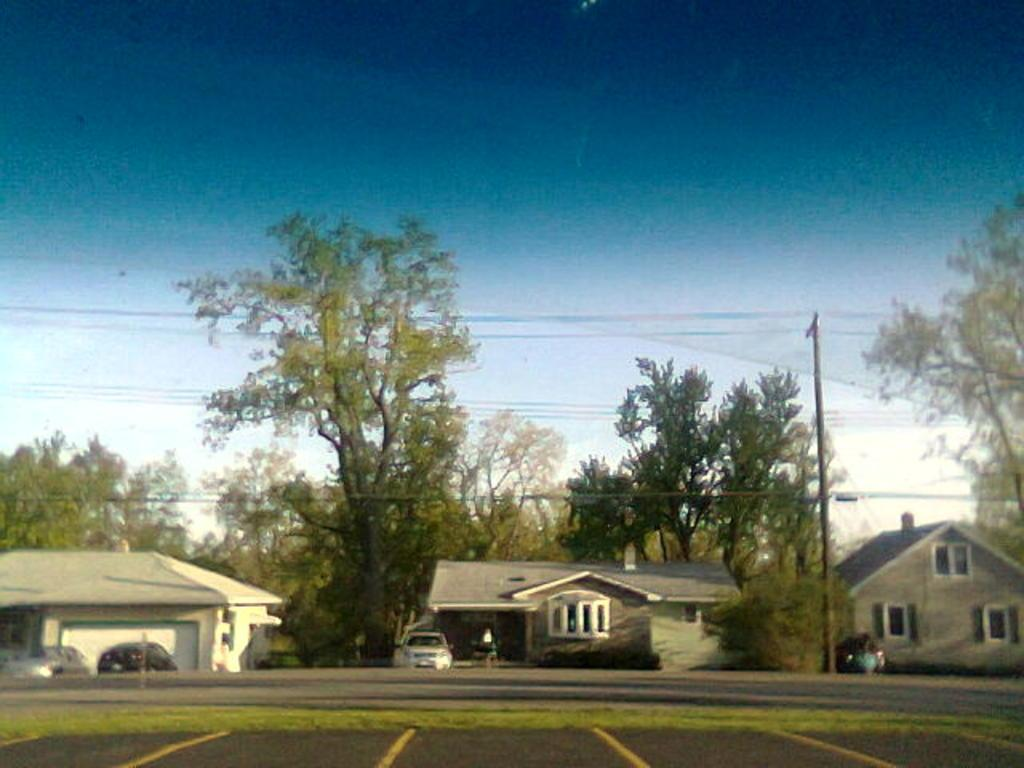What type of vehicles can be seen on the road in the image? There are cars on the road in the image. What type of structures are visible in the image? There are buildings in the image. What type of vegetation is present in the image? Grass and trees are visible in the image. What object can be seen in the image that is used for displaying information or advertisements? There is a board in the image. What object can be seen in the image that is used for supporting or holding up other objects? There is a pole in the image. What is attached to the pole in the image? Wires are tied to the pole. What is visible at the top of the image? The sky is visible at the top of the image. How many feet are visible on the board in the image? There are no feet visible on the board in the image. What type of servant is shown working in the image? There is no servant present in the image. 